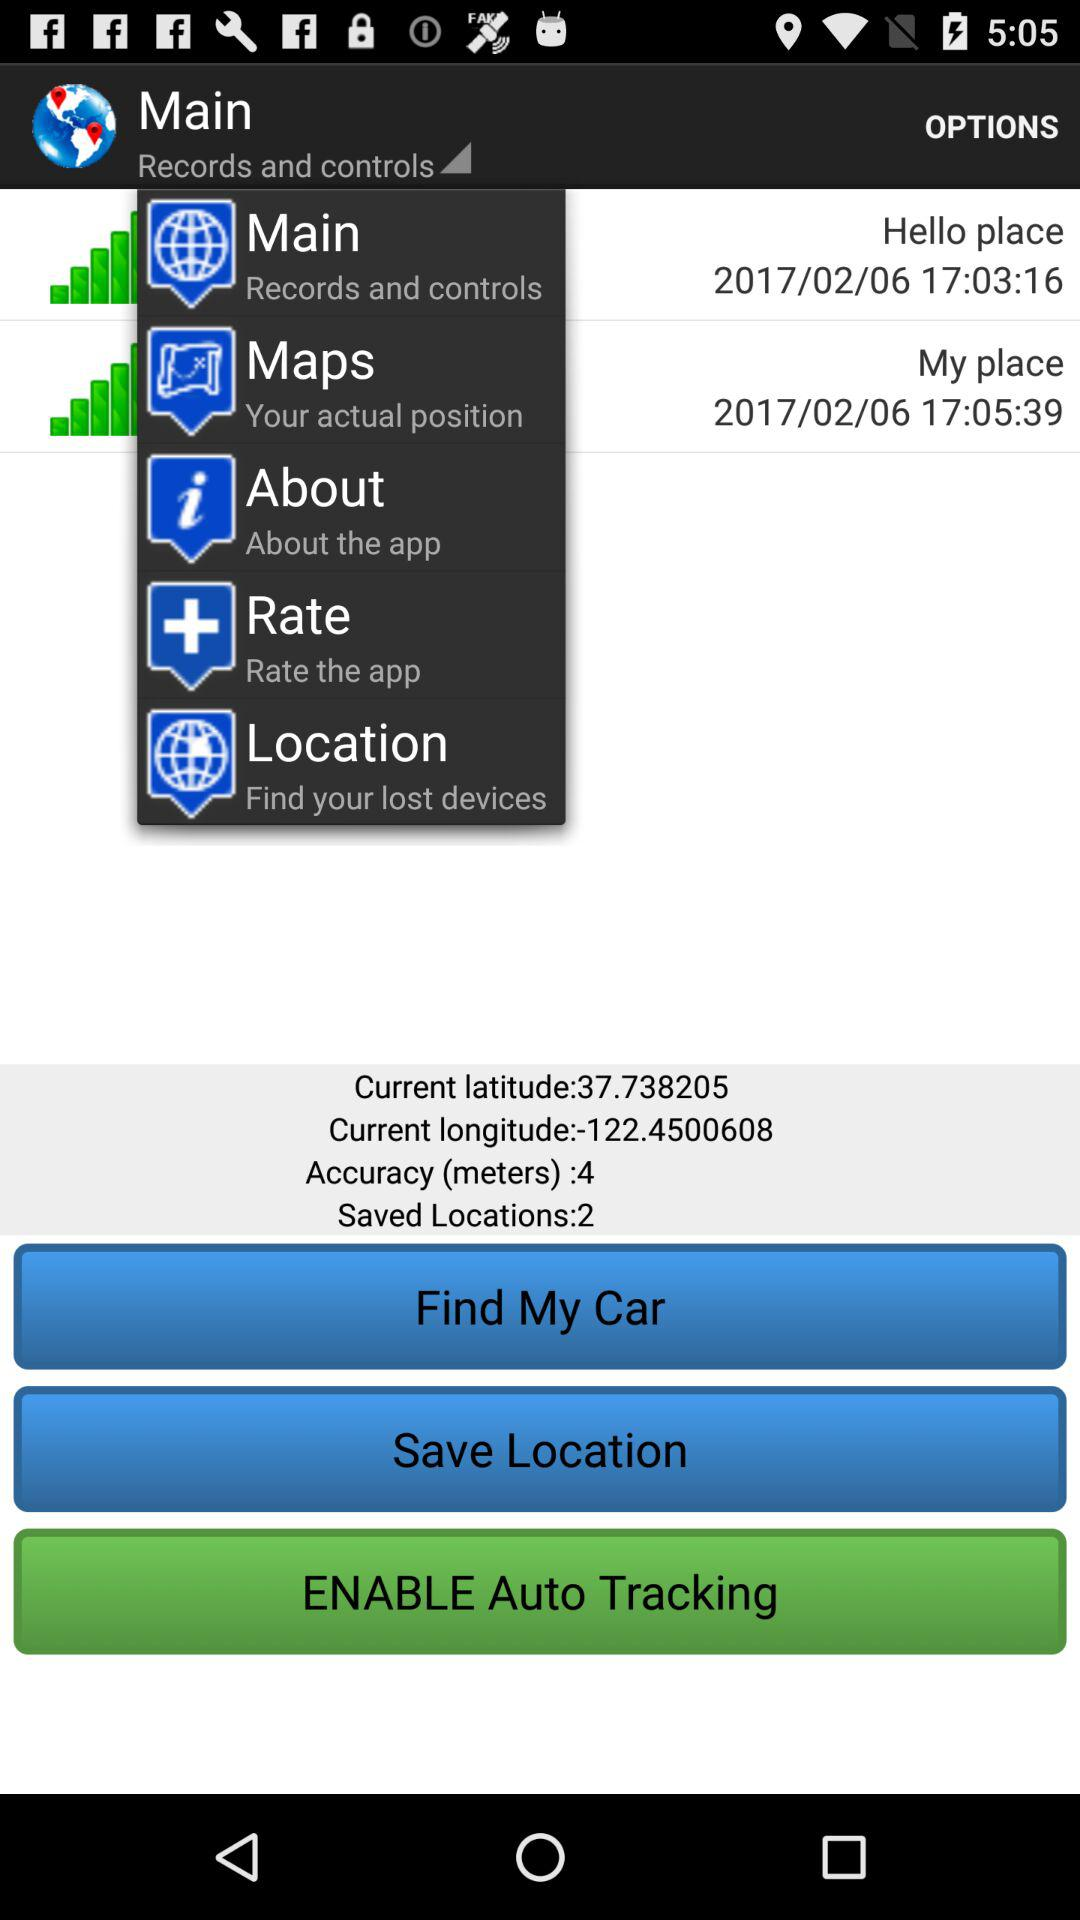What is the count of "Accuracy"? The count of "Accuracy" is 4. 